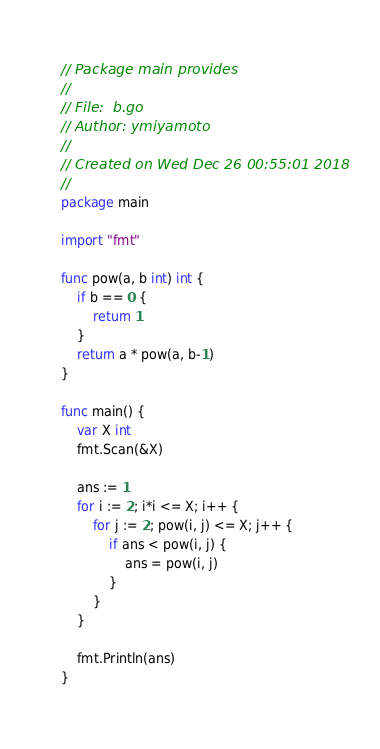Convert code to text. <code><loc_0><loc_0><loc_500><loc_500><_Go_>// Package main provides
//
// File:  b.go
// Author: ymiyamoto
//
// Created on Wed Dec 26 00:55:01 2018
//
package main

import "fmt"

func pow(a, b int) int {
	if b == 0 {
		return 1
	}
	return a * pow(a, b-1)
}

func main() {
	var X int
	fmt.Scan(&X)

	ans := 1
	for i := 2; i*i <= X; i++ {
		for j := 2; pow(i, j) <= X; j++ {
			if ans < pow(i, j) {
				ans = pow(i, j)
			}
		}
	}

	fmt.Println(ans)
}
</code> 